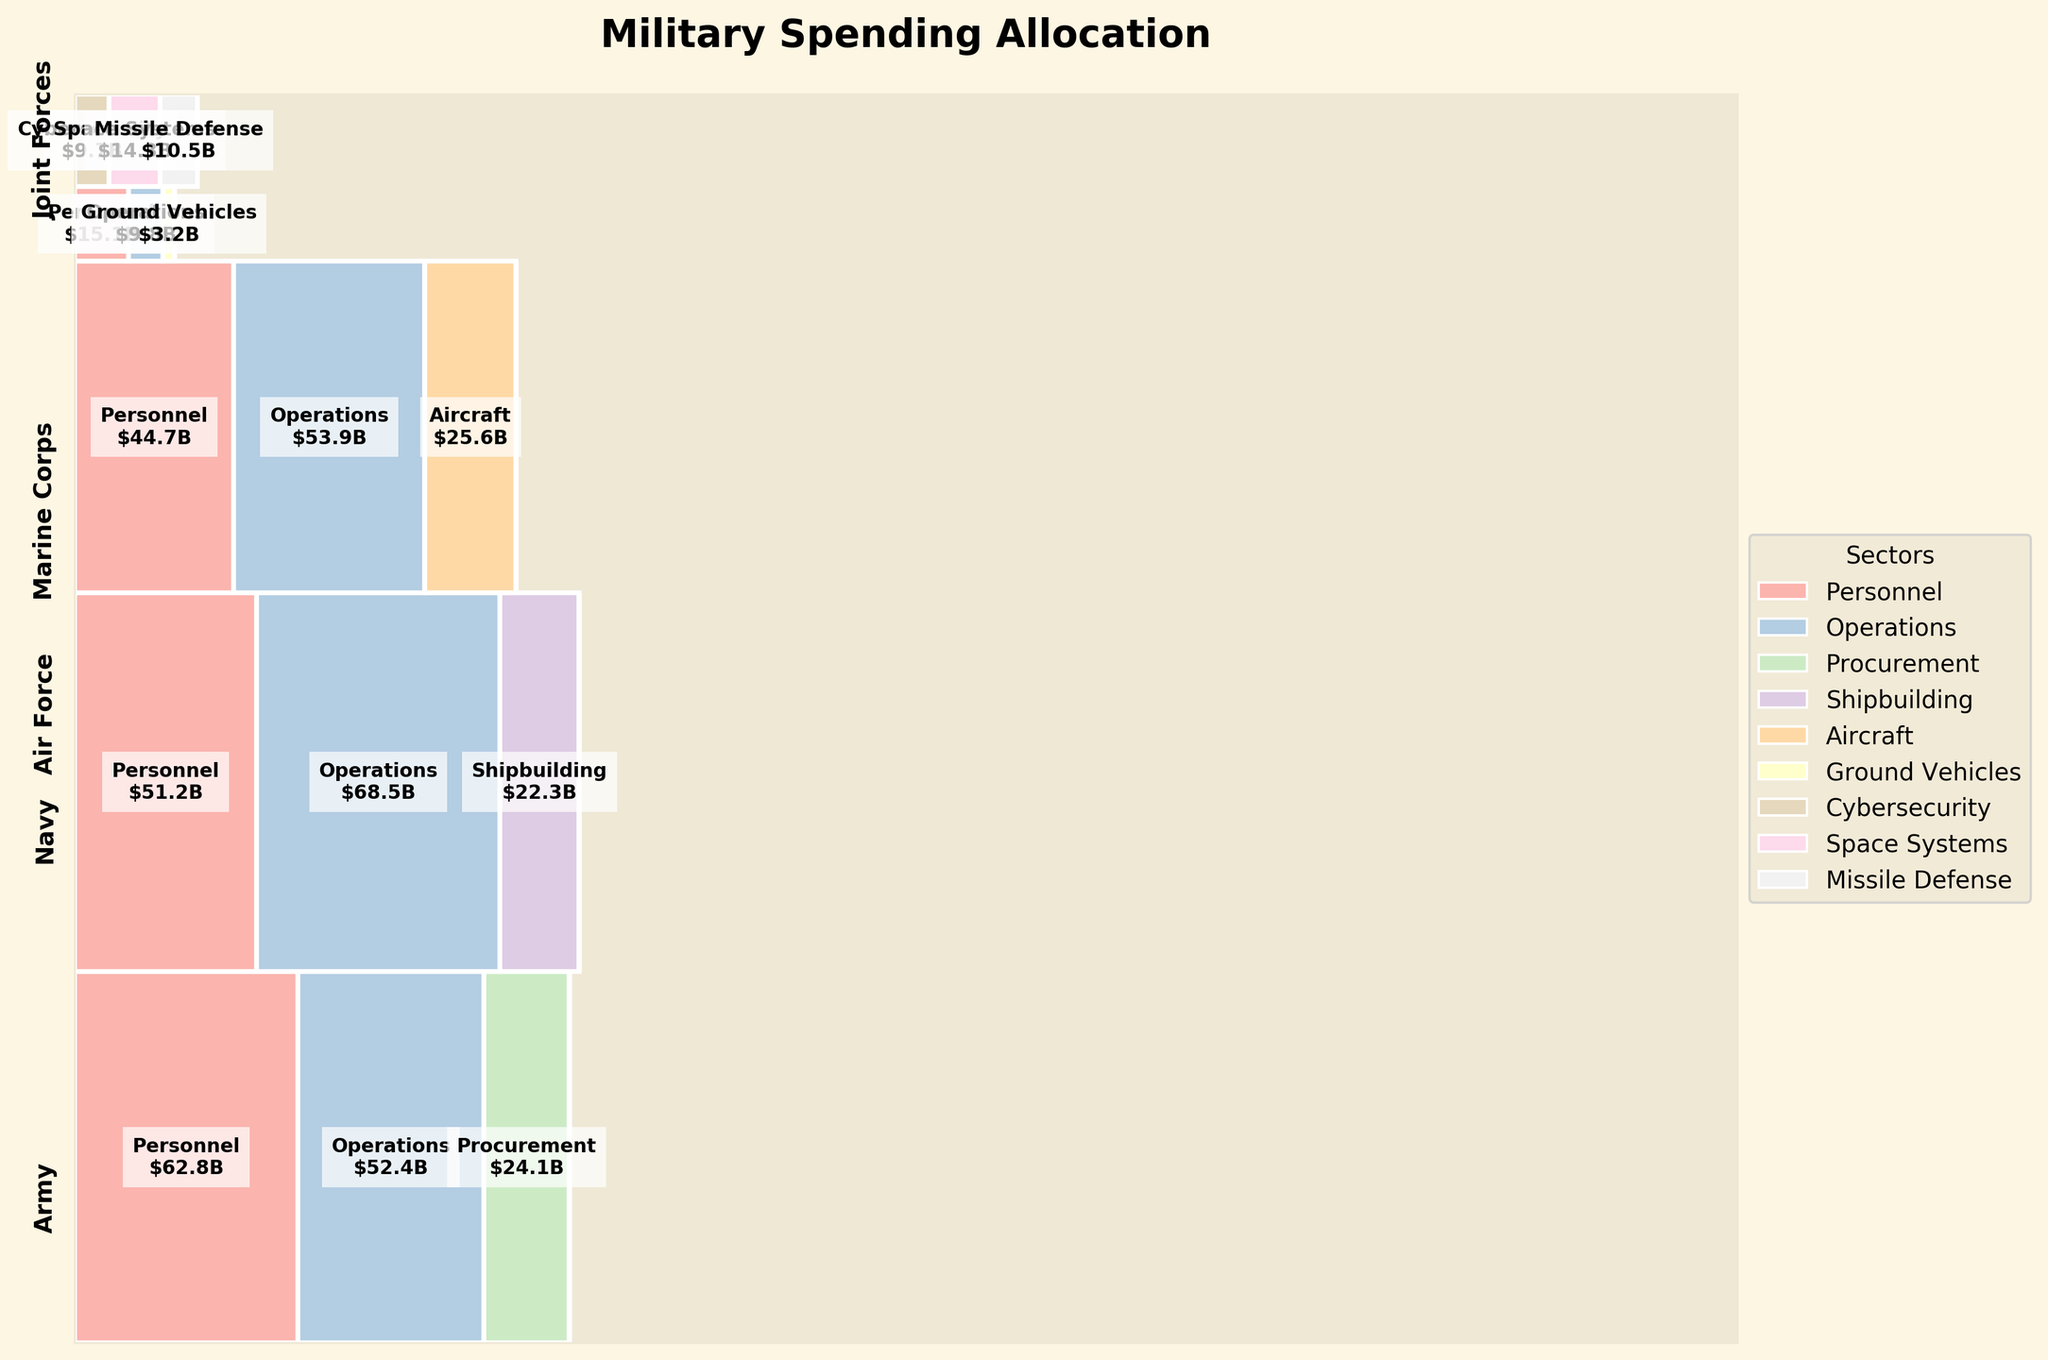Which branch has the highest total spending on operations? To find which branch has the highest spending on operations, look at the labeled sectors within each branch's area of the mosaic plot. Sum up the spending values listed for the "Operations" sector for each branch. The branch with the highest total value is the answer.
Answer: Navy Which sectors have expenditures in the Joint Forces branch? Identify the sectors within the Joint Forces area by reading the sector labels. The Joint Forces branch encompasses all sectors with a distinct color and spending value labeled within its compartment.
Answer: Cybersecurity, Space Systems, Missile Defense What is the total spending of the Air Force branch? To find the total spending of the Air Force branch, add up the spending values for each sector within the Air Force area. Those labeled sectors and their corresponding values are summed up.
Answer: 124.2 billion USD Comparing the Army’s procurement and the Navy’s shipbuilding, which sector has higher spending? Identify and compare the spending values for the Army's "Procurement" and the Navy's "Shipbuilding" sectors based on their labeled spending amounts. The sector with the higher value is the answer.
Answer: Army's Procurement What is the total spending on personnel across all branches? To calculate the total spending on personnel, sum up the spending values for all "Personnel" sectors across all branches: Army, Navy, Air Force, Marine Corps. Sum their respective values according to the plot labels.
Answer: 173.8 billion USD Which branch has the smallest total spending, and what is its amount? Examine each branch's area on the plot and sum up the spending values within each branch's compartment. Determine the smallest total value and identify the corresponding branch.
Answer: Marine Corps, 28.1 billion USD What is the proportion of spending on missile defense in relation to the total spending on Joint Forces? First, determine the spending value for the "Missile Defense" sector in the Joint Forces area. Then, sum the total spending values for all sectors within Joint Forces. Calculate the proportion by dividing the Missile Defense value by the total spending of Joint Forces and present it as a percentage.
Answer: 21.1% Which sector in the Navy has the highest spending, and what is its amount? Identify the sector with the highest spending value within the Navy area by comparing the labeled values for each sector within the Navy portion of the mosaic plot.
Answer: Operations, 68.5 billion USD Comparing the total spending between the Marine Corps and Joint Forces, which is higher? Sum the spending amounts for all sectors within the Marine Corps area and separately within the Joint Forces area. Compare the totals to identify which is higher.
Answer: Joint Forces What is the total spending on technology sectors (cybersecurity, space systems, missile defense) across all branches? Identify the spending values for "Cybersecurity", "Space Systems", and "Missile Defense" in the Joint Forces area and sum them. These are the technology sectors accounted for in the mosaic plot.
Answer: 34.5 billion USD 